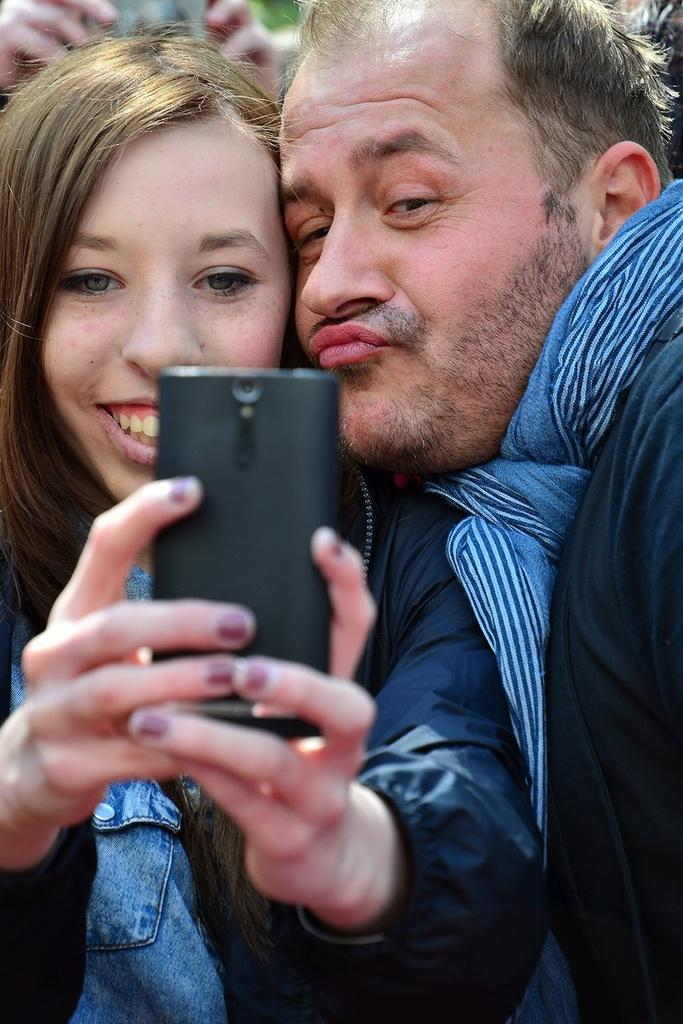How many people are in the image? There is a group of people in the image. Can you describe the clothing of one of the individuals? One woman is wearing a jacket. What object is the woman holding in her hand? The woman is holding a mobile in her hand. What day of the week is depicted in the image? The image does not show a specific day of the week. 